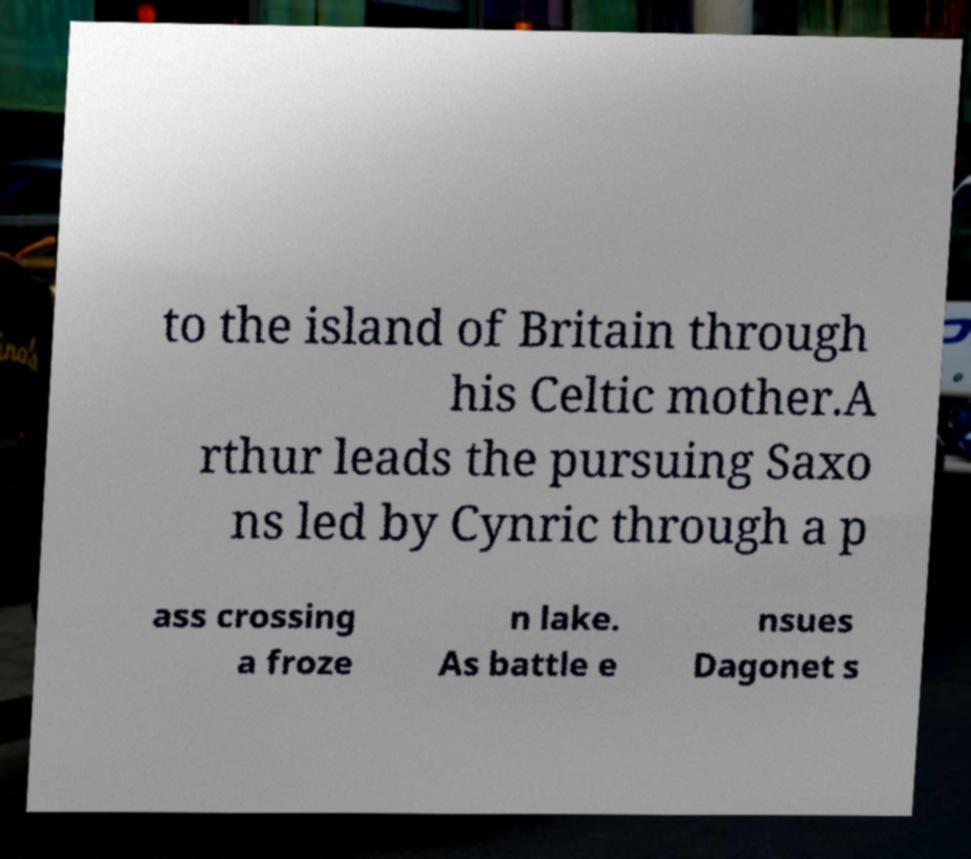Please identify and transcribe the text found in this image. to the island of Britain through his Celtic mother.A rthur leads the pursuing Saxo ns led by Cynric through a p ass crossing a froze n lake. As battle e nsues Dagonet s 